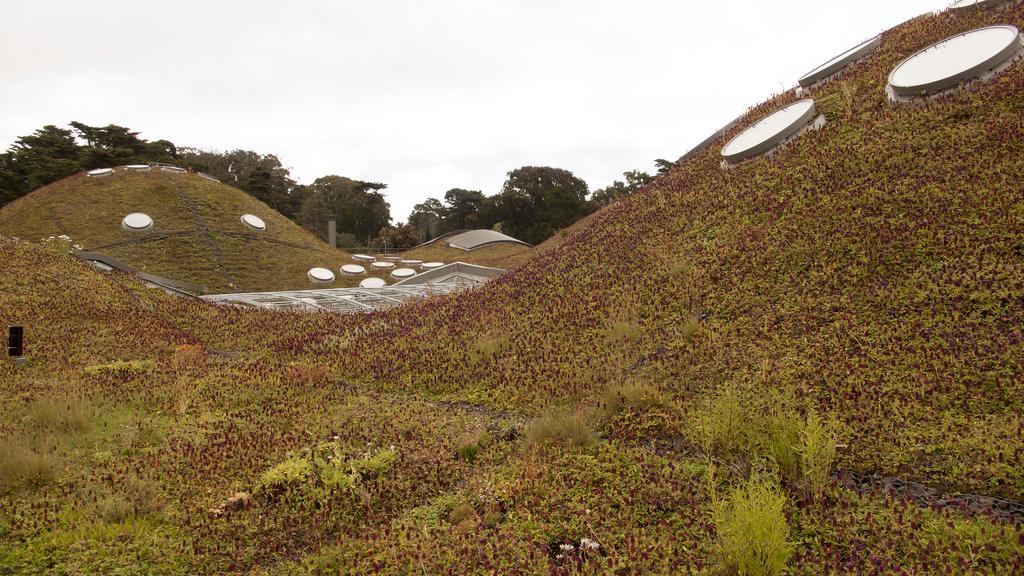Describe this image in one or two sentences. In the background we can see the sky. In this picture we can see trees, plants, objects and inclined grass surfaces. 